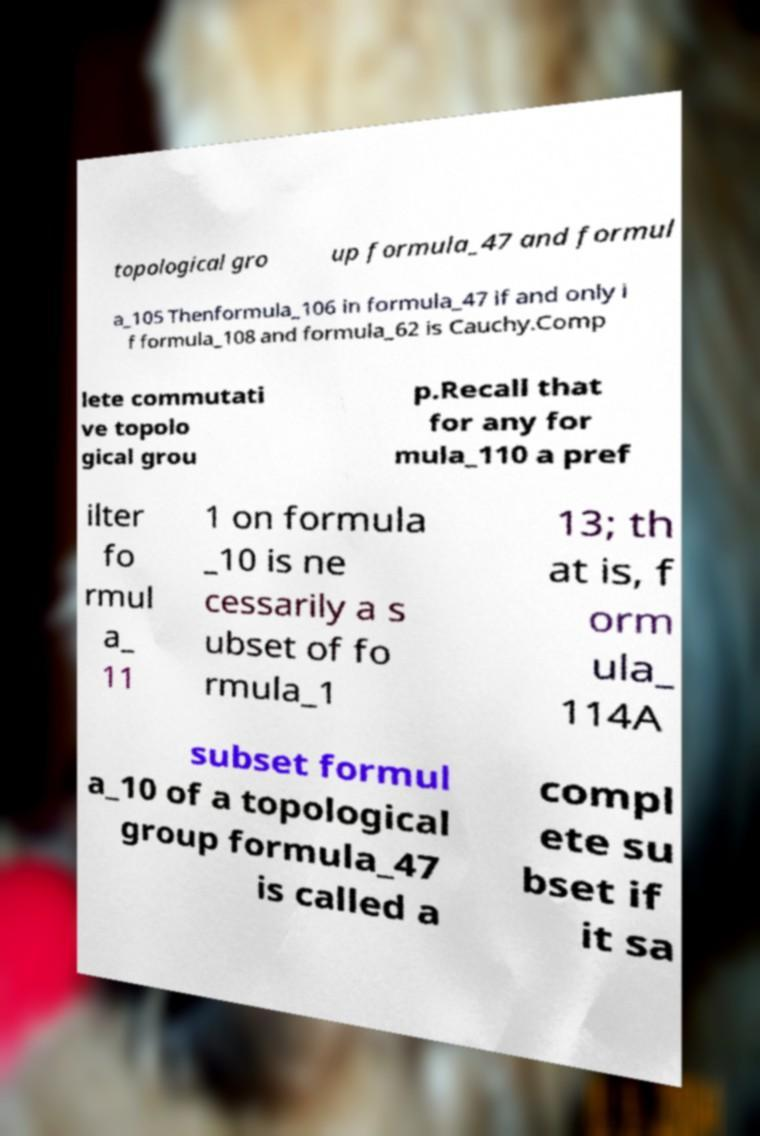Can you accurately transcribe the text from the provided image for me? topological gro up formula_47 and formul a_105 Thenformula_106 in formula_47 if and only i f formula_108 and formula_62 is Cauchy.Comp lete commutati ve topolo gical grou p.Recall that for any for mula_110 a pref ilter fo rmul a_ 11 1 on formula _10 is ne cessarily a s ubset of fo rmula_1 13; th at is, f orm ula_ 114A subset formul a_10 of a topological group formula_47 is called a compl ete su bset if it sa 